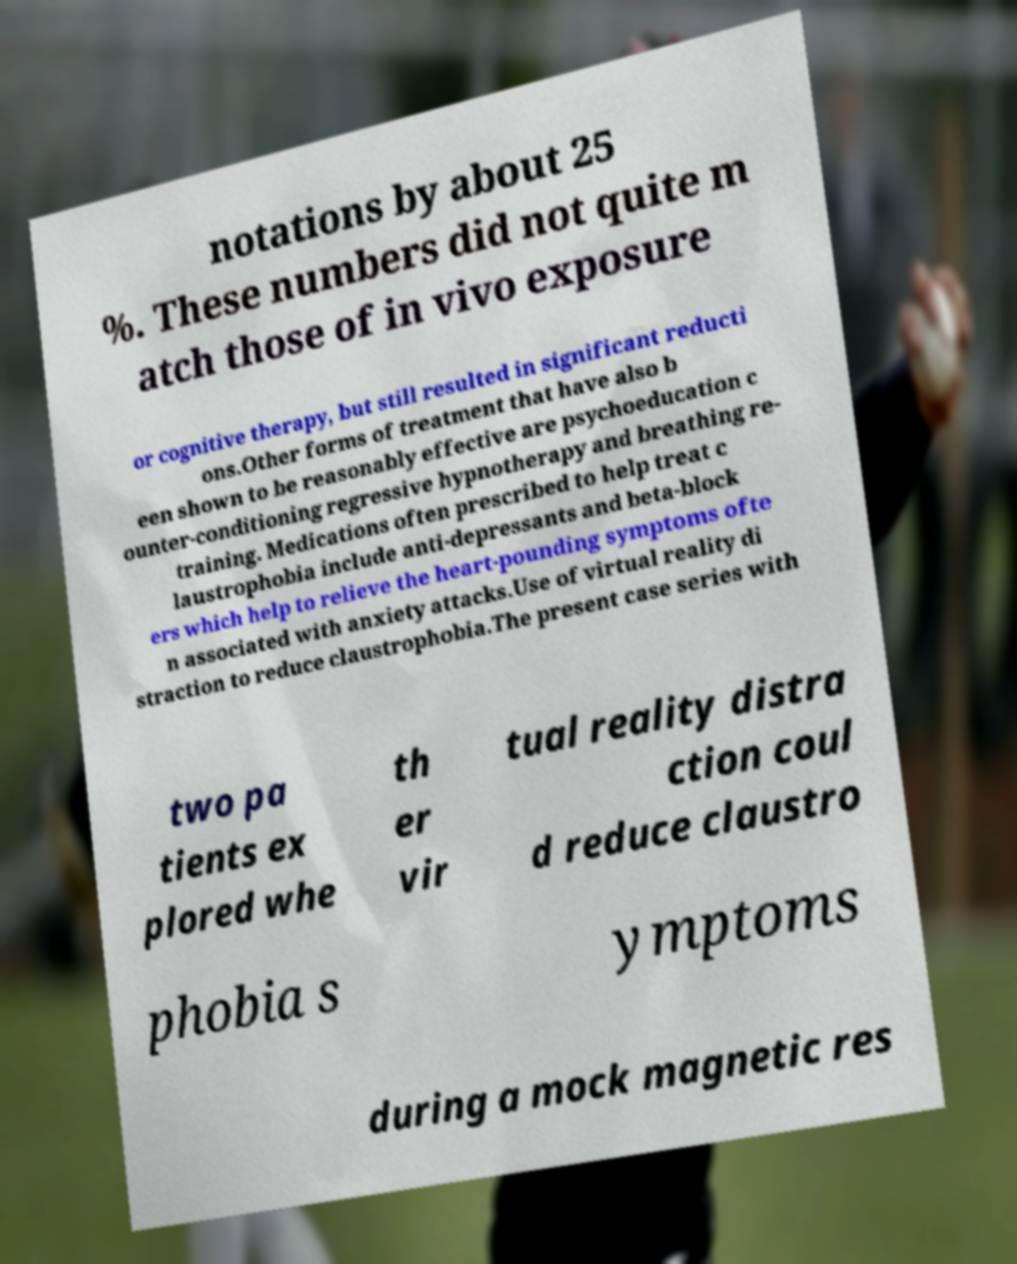Could you assist in decoding the text presented in this image and type it out clearly? notations by about 25 %. These numbers did not quite m atch those of in vivo exposure or cognitive therapy, but still resulted in significant reducti ons.Other forms of treatment that have also b een shown to be reasonably effective are psychoeducation c ounter-conditioning regressive hypnotherapy and breathing re- training. Medications often prescribed to help treat c laustrophobia include anti-depressants and beta-block ers which help to relieve the heart-pounding symptoms ofte n associated with anxiety attacks.Use of virtual reality di straction to reduce claustrophobia.The present case series with two pa tients ex plored whe th er vir tual reality distra ction coul d reduce claustro phobia s ymptoms during a mock magnetic res 